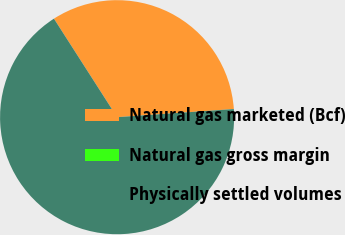Convert chart. <chart><loc_0><loc_0><loc_500><loc_500><pie_chart><fcel>Natural gas marketed (Bcf)<fcel>Natural gas gross margin<fcel>Physically settled volumes<nl><fcel>32.96%<fcel>0.0%<fcel>67.03%<nl></chart> 